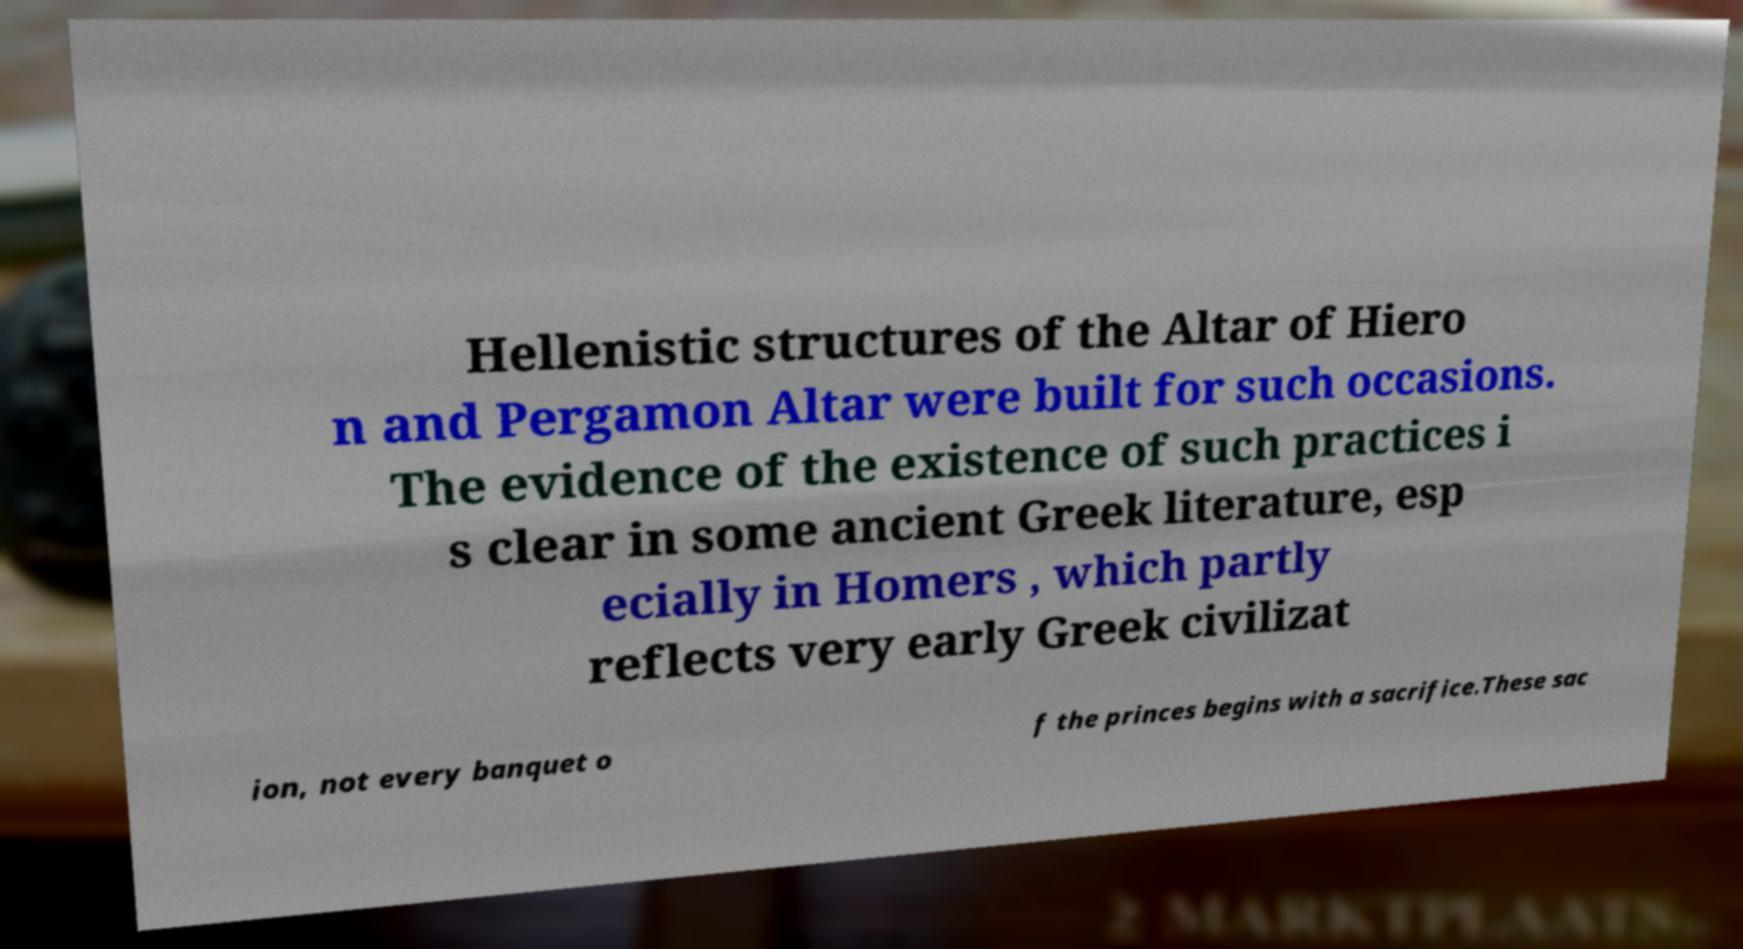There's text embedded in this image that I need extracted. Can you transcribe it verbatim? Hellenistic structures of the Altar of Hiero n and Pergamon Altar were built for such occasions. The evidence of the existence of such practices i s clear in some ancient Greek literature, esp ecially in Homers , which partly reflects very early Greek civilizat ion, not every banquet o f the princes begins with a sacrifice.These sac 